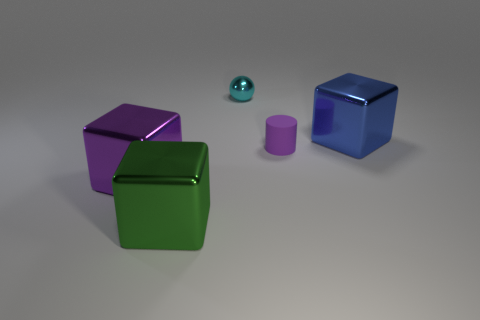Subtract all cyan blocks. Subtract all green spheres. How many blocks are left? 3 Add 2 small metal blocks. How many objects exist? 7 Subtract all spheres. How many objects are left? 4 Add 4 green metal objects. How many green metal objects are left? 5 Add 2 cyan metal objects. How many cyan metal objects exist? 3 Subtract 0 green cylinders. How many objects are left? 5 Subtract all small metallic spheres. Subtract all blue metal blocks. How many objects are left? 3 